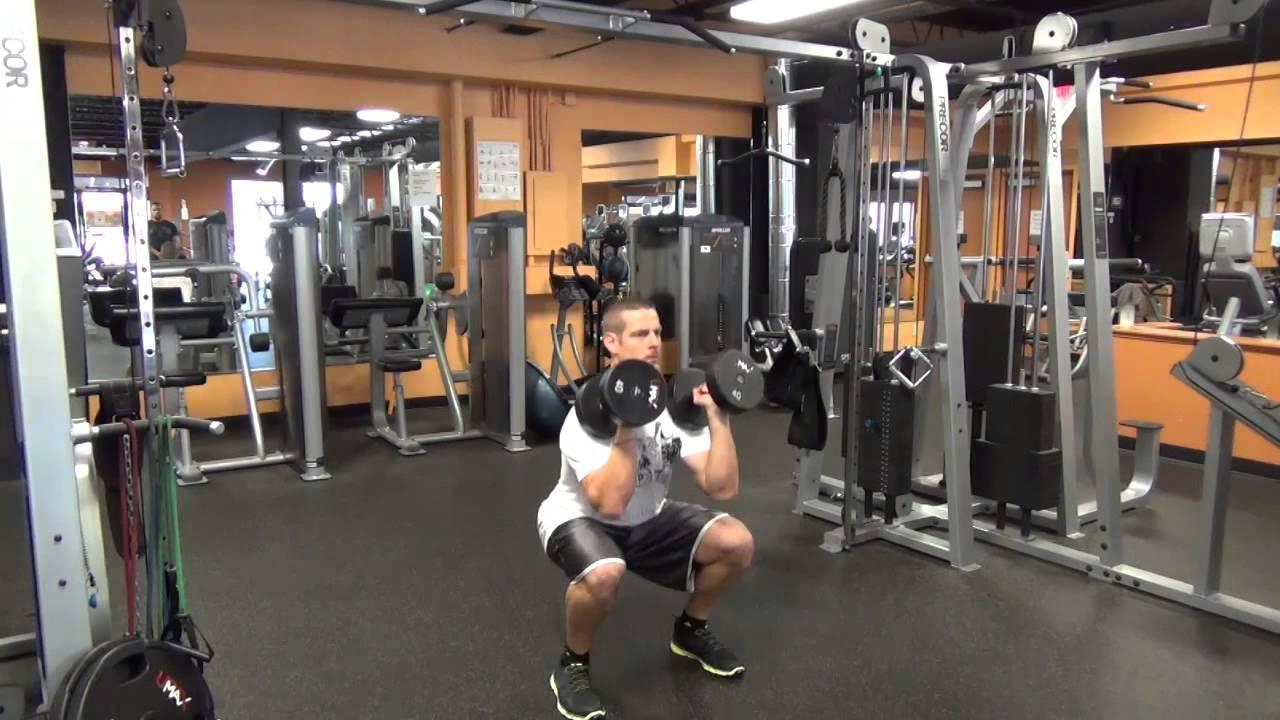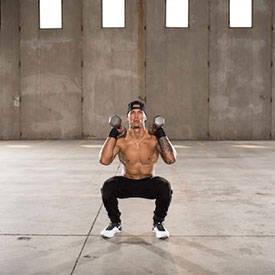The first image is the image on the left, the second image is the image on the right. Analyze the images presented: Is the assertion "A single person is lifting weights in each of the images." valid? Answer yes or no. Yes. The first image is the image on the left, the second image is the image on the right. Examine the images to the left and right. Is the description "A woman is lifting weights in a squat position." accurate? Answer yes or no. No. 